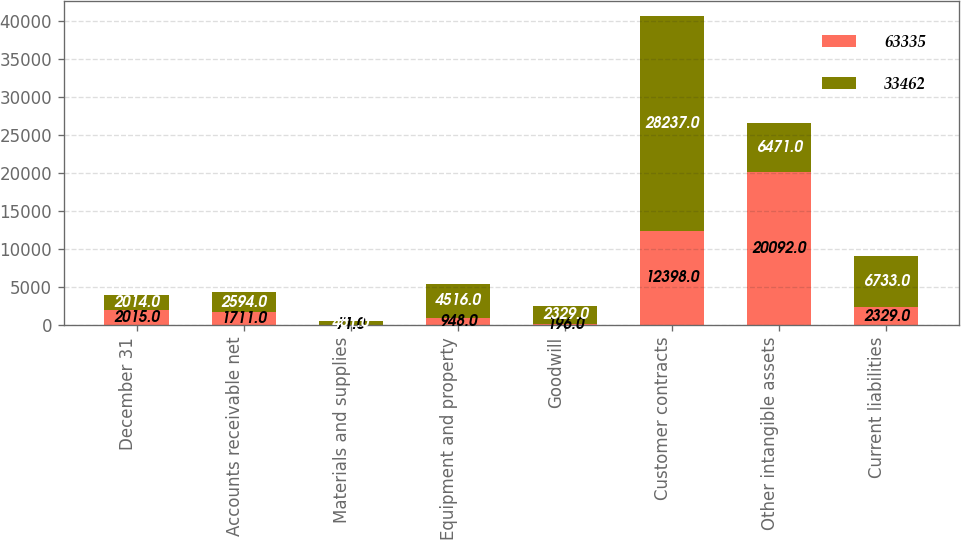<chart> <loc_0><loc_0><loc_500><loc_500><stacked_bar_chart><ecel><fcel>December 31<fcel>Accounts receivable net<fcel>Materials and supplies<fcel>Equipment and property<fcel>Goodwill<fcel>Customer contracts<fcel>Other intangible assets<fcel>Current liabilities<nl><fcel>63335<fcel>2015<fcel>1711<fcel>71<fcel>948<fcel>196<fcel>12398<fcel>20092<fcel>2329<nl><fcel>33462<fcel>2014<fcel>2594<fcel>481<fcel>4516<fcel>2329<fcel>28237<fcel>6471<fcel>6733<nl></chart> 